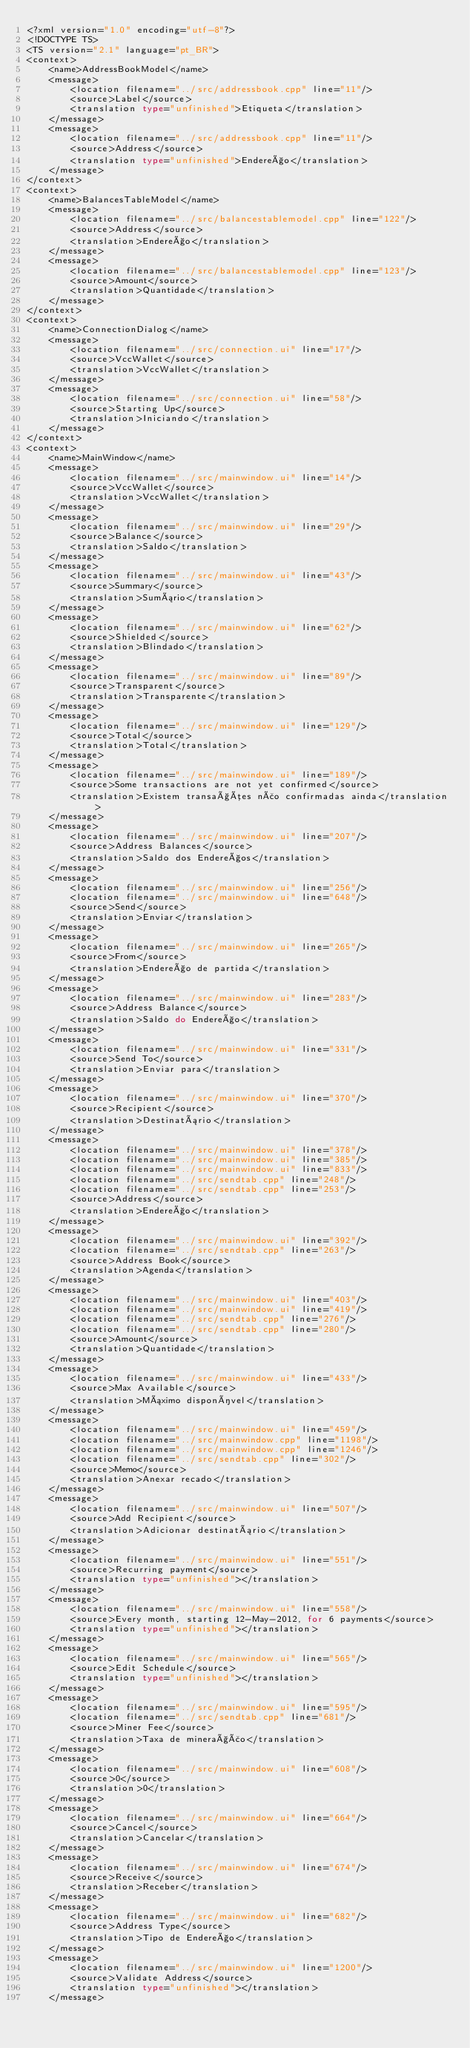<code> <loc_0><loc_0><loc_500><loc_500><_TypeScript_><?xml version="1.0" encoding="utf-8"?>
<!DOCTYPE TS>
<TS version="2.1" language="pt_BR">
<context>
    <name>AddressBookModel</name>
    <message>
        <location filename="../src/addressbook.cpp" line="11"/>
        <source>Label</source>
        <translation type="unfinished">Etiqueta</translation>
    </message>
    <message>
        <location filename="../src/addressbook.cpp" line="11"/>
        <source>Address</source>
        <translation type="unfinished">Endereço</translation>
    </message>
</context>
<context>
    <name>BalancesTableModel</name>
    <message>
        <location filename="../src/balancestablemodel.cpp" line="122"/>
        <source>Address</source>
        <translation>Endereço</translation>
    </message>
    <message>
        <location filename="../src/balancestablemodel.cpp" line="123"/>
        <source>Amount</source>
        <translation>Quantidade</translation>
    </message>
</context>
<context>
    <name>ConnectionDialog</name>
    <message>
        <location filename="../src/connection.ui" line="17"/>
        <source>VccWallet</source>
        <translation>VccWallet</translation>
    </message>
    <message>
        <location filename="../src/connection.ui" line="58"/>
        <source>Starting Up</source>
        <translation>Iniciando</translation>
    </message>
</context>
<context>
    <name>MainWindow</name>
    <message>
        <location filename="../src/mainwindow.ui" line="14"/>
        <source>VccWallet</source>
        <translation>VccWallet</translation>
    </message>
    <message>
        <location filename="../src/mainwindow.ui" line="29"/>
        <source>Balance</source>
        <translation>Saldo</translation>
    </message>
    <message>
        <location filename="../src/mainwindow.ui" line="43"/>
        <source>Summary</source>
        <translation>Sumário</translation>
    </message>
    <message>
        <location filename="../src/mainwindow.ui" line="62"/>
        <source>Shielded</source>
        <translation>Blindado</translation>
    </message>
    <message>
        <location filename="../src/mainwindow.ui" line="89"/>
        <source>Transparent</source>
        <translation>Transparente</translation>
    </message>
    <message>
        <location filename="../src/mainwindow.ui" line="129"/>
        <source>Total</source>
        <translation>Total</translation>
    </message>
    <message>
        <location filename="../src/mainwindow.ui" line="189"/>
        <source>Some transactions are not yet confirmed</source>
        <translation>Existem transações não confirmadas ainda</translation>
    </message>
    <message>
        <location filename="../src/mainwindow.ui" line="207"/>
        <source>Address Balances</source>
        <translation>Saldo dos Endereços</translation>
    </message>
    <message>
        <location filename="../src/mainwindow.ui" line="256"/>
        <location filename="../src/mainwindow.ui" line="648"/>
        <source>Send</source>
        <translation>Enviar</translation>
    </message>
    <message>
        <location filename="../src/mainwindow.ui" line="265"/>
        <source>From</source>
        <translation>Endereço de partida</translation>
    </message>
    <message>
        <location filename="../src/mainwindow.ui" line="283"/>
        <source>Address Balance</source>
        <translation>Saldo do Endereço</translation>
    </message>
    <message>
        <location filename="../src/mainwindow.ui" line="331"/>
        <source>Send To</source>
        <translation>Enviar para</translation>
    </message>
    <message>
        <location filename="../src/mainwindow.ui" line="370"/>
        <source>Recipient</source>
        <translation>Destinatário</translation>
    </message>
    <message>
        <location filename="../src/mainwindow.ui" line="378"/>
        <location filename="../src/mainwindow.ui" line="385"/>
        <location filename="../src/mainwindow.ui" line="833"/>
        <location filename="../src/sendtab.cpp" line="248"/>
        <location filename="../src/sendtab.cpp" line="253"/>
        <source>Address</source>
        <translation>Endereço</translation>
    </message>
    <message>
        <location filename="../src/mainwindow.ui" line="392"/>
        <location filename="../src/sendtab.cpp" line="263"/>
        <source>Address Book</source>
        <translation>Agenda</translation>
    </message>
    <message>
        <location filename="../src/mainwindow.ui" line="403"/>
        <location filename="../src/mainwindow.ui" line="419"/>
        <location filename="../src/sendtab.cpp" line="276"/>
        <location filename="../src/sendtab.cpp" line="280"/>
        <source>Amount</source>
        <translation>Quantidade</translation>
    </message>
    <message>
        <location filename="../src/mainwindow.ui" line="433"/>
        <source>Max Available</source>
        <translation>Máximo disponível</translation>
    </message>
    <message>
        <location filename="../src/mainwindow.ui" line="459"/>
        <location filename="../src/mainwindow.cpp" line="1198"/>
        <location filename="../src/mainwindow.cpp" line="1246"/>
        <location filename="../src/sendtab.cpp" line="302"/>
        <source>Memo</source>
        <translation>Anexar recado</translation>
    </message>
    <message>
        <location filename="../src/mainwindow.ui" line="507"/>
        <source>Add Recipient</source>
        <translation>Adicionar destinatário</translation>
    </message>
    <message>
        <location filename="../src/mainwindow.ui" line="551"/>
        <source>Recurring payment</source>
        <translation type="unfinished"></translation>
    </message>
    <message>
        <location filename="../src/mainwindow.ui" line="558"/>
        <source>Every month, starting 12-May-2012, for 6 payments</source>
        <translation type="unfinished"></translation>
    </message>
    <message>
        <location filename="../src/mainwindow.ui" line="565"/>
        <source>Edit Schedule</source>
        <translation type="unfinished"></translation>
    </message>
    <message>
        <location filename="../src/mainwindow.ui" line="595"/>
        <location filename="../src/sendtab.cpp" line="681"/>
        <source>Miner Fee</source>
        <translation>Taxa de mineração</translation>
    </message>
    <message>
        <location filename="../src/mainwindow.ui" line="608"/>
        <source>0</source>
        <translation>0</translation>
    </message>
    <message>
        <location filename="../src/mainwindow.ui" line="664"/>
        <source>Cancel</source>
        <translation>Cancelar</translation>
    </message>
    <message>
        <location filename="../src/mainwindow.ui" line="674"/>
        <source>Receive</source>
        <translation>Receber</translation>
    </message>
    <message>
        <location filename="../src/mainwindow.ui" line="682"/>
        <source>Address Type</source>
        <translation>Tipo de Endereço</translation>
    </message>
    <message>
        <location filename="../src/mainwindow.ui" line="1200"/>
        <source>Validate Address</source>
        <translation type="unfinished"></translation>
    </message></code> 